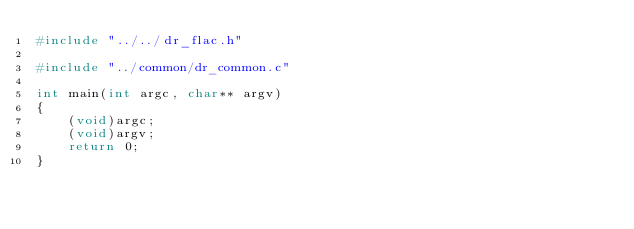<code> <loc_0><loc_0><loc_500><loc_500><_C_>#include "../../dr_flac.h"

#include "../common/dr_common.c"

int main(int argc, char** argv)
{
    (void)argc;
    (void)argv;
    return 0;
}
</code> 